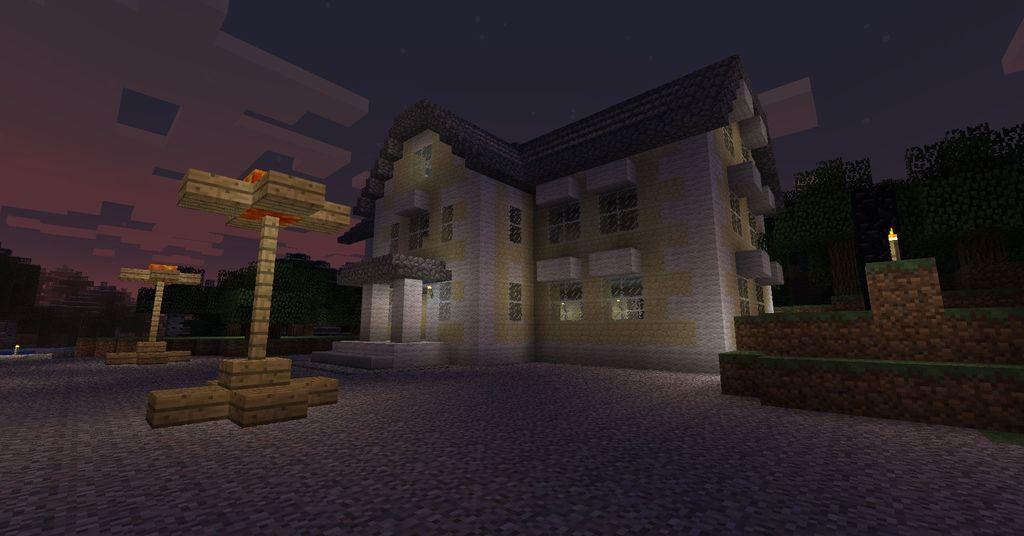What type of structure is visible in the image? There is a building in the image. What architectural feature can be seen on the building? There are windows visible in the image. What is the nature of the image? The image is animated. What is one of the interior elements of the building? There is a wall in the image. What type of natural environment is visible in the image? There are trees in the image. What surface is visible in the image? There is a floor in the image. How many objects are on the left side of the image? There are two objects on the left side of the image. What discovery does the friend make in the image? There is no friend present in the image, and therefore no discovery can be made. 